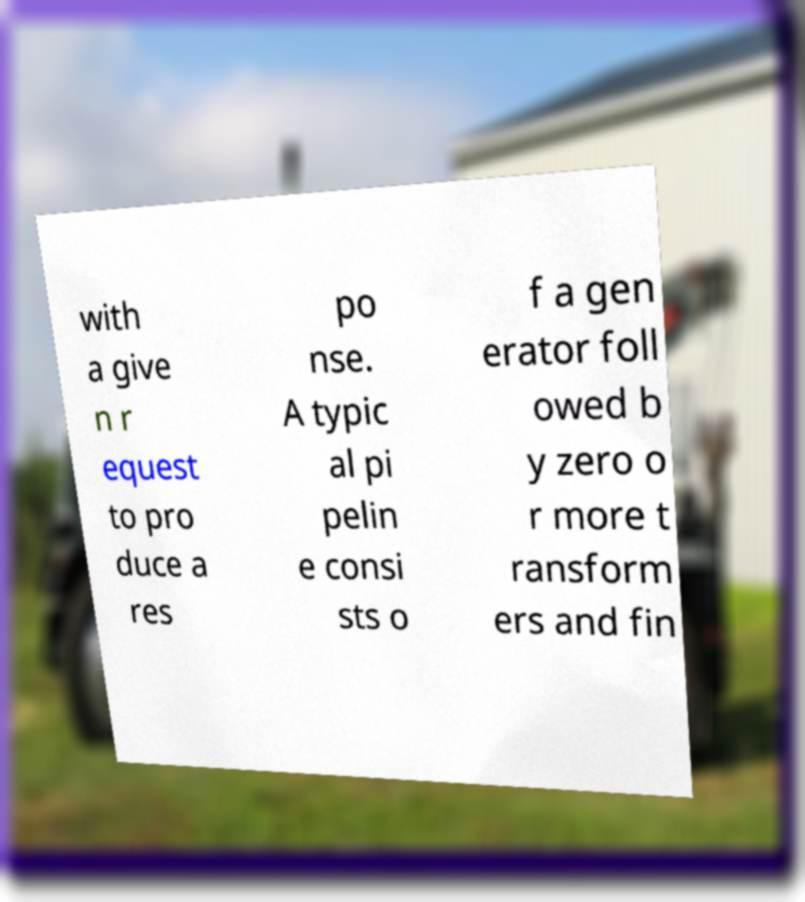What messages or text are displayed in this image? I need them in a readable, typed format. with a give n r equest to pro duce a res po nse. A typic al pi pelin e consi sts o f a gen erator foll owed b y zero o r more t ransform ers and fin 